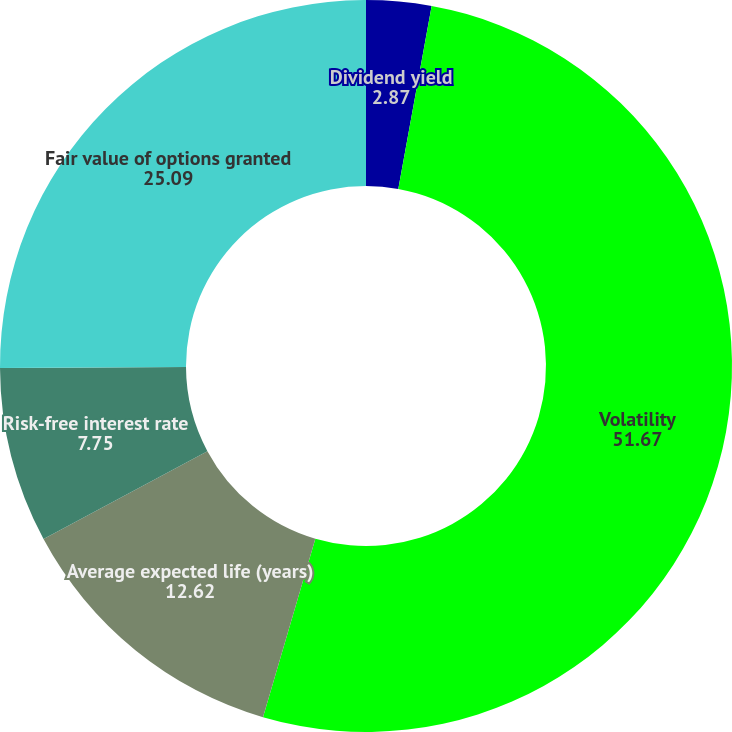Convert chart to OTSL. <chart><loc_0><loc_0><loc_500><loc_500><pie_chart><fcel>Dividend yield<fcel>Volatility<fcel>Average expected life (years)<fcel>Risk-free interest rate<fcel>Fair value of options granted<nl><fcel>2.87%<fcel>51.67%<fcel>12.62%<fcel>7.75%<fcel>25.09%<nl></chart> 